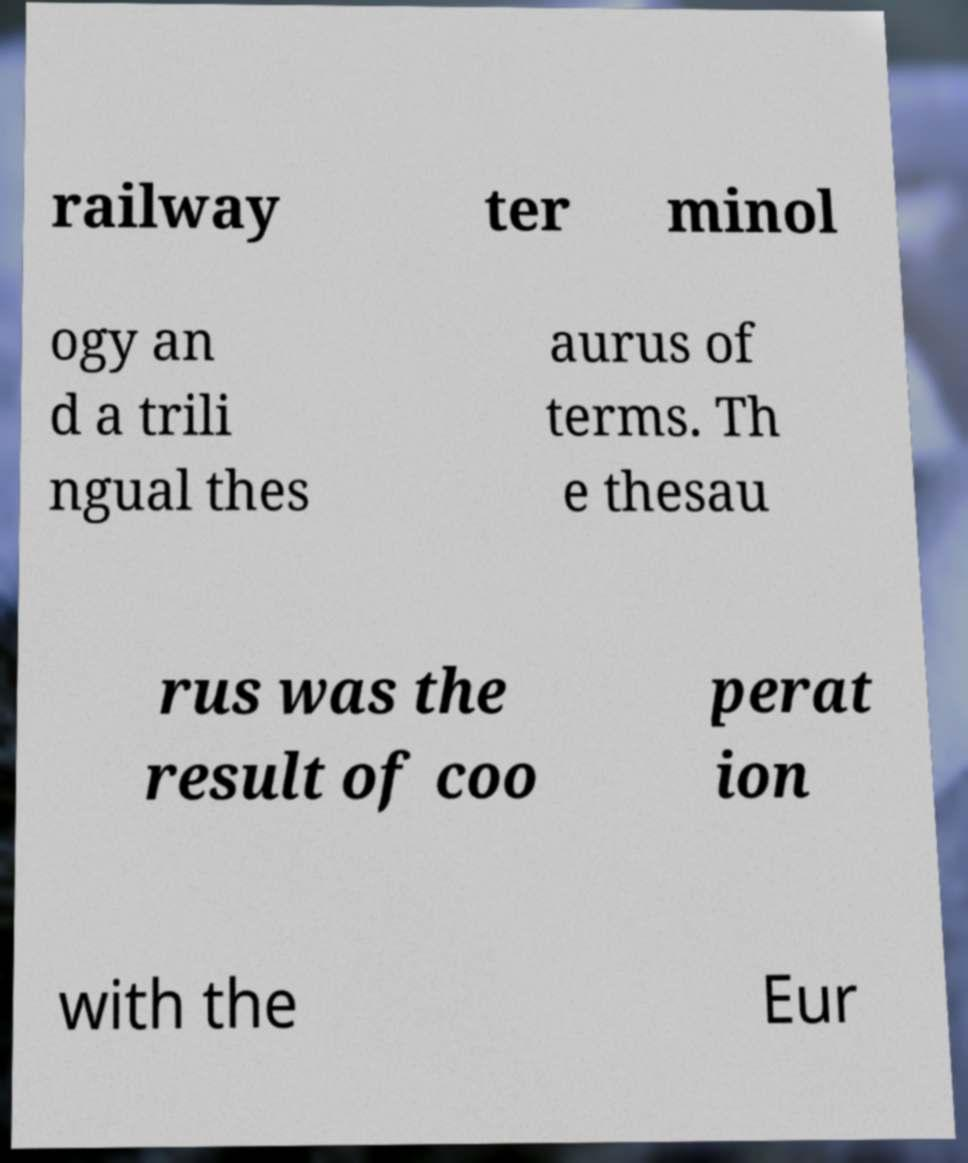There's text embedded in this image that I need extracted. Can you transcribe it verbatim? railway ter minol ogy an d a trili ngual thes aurus of terms. Th e thesau rus was the result of coo perat ion with the Eur 